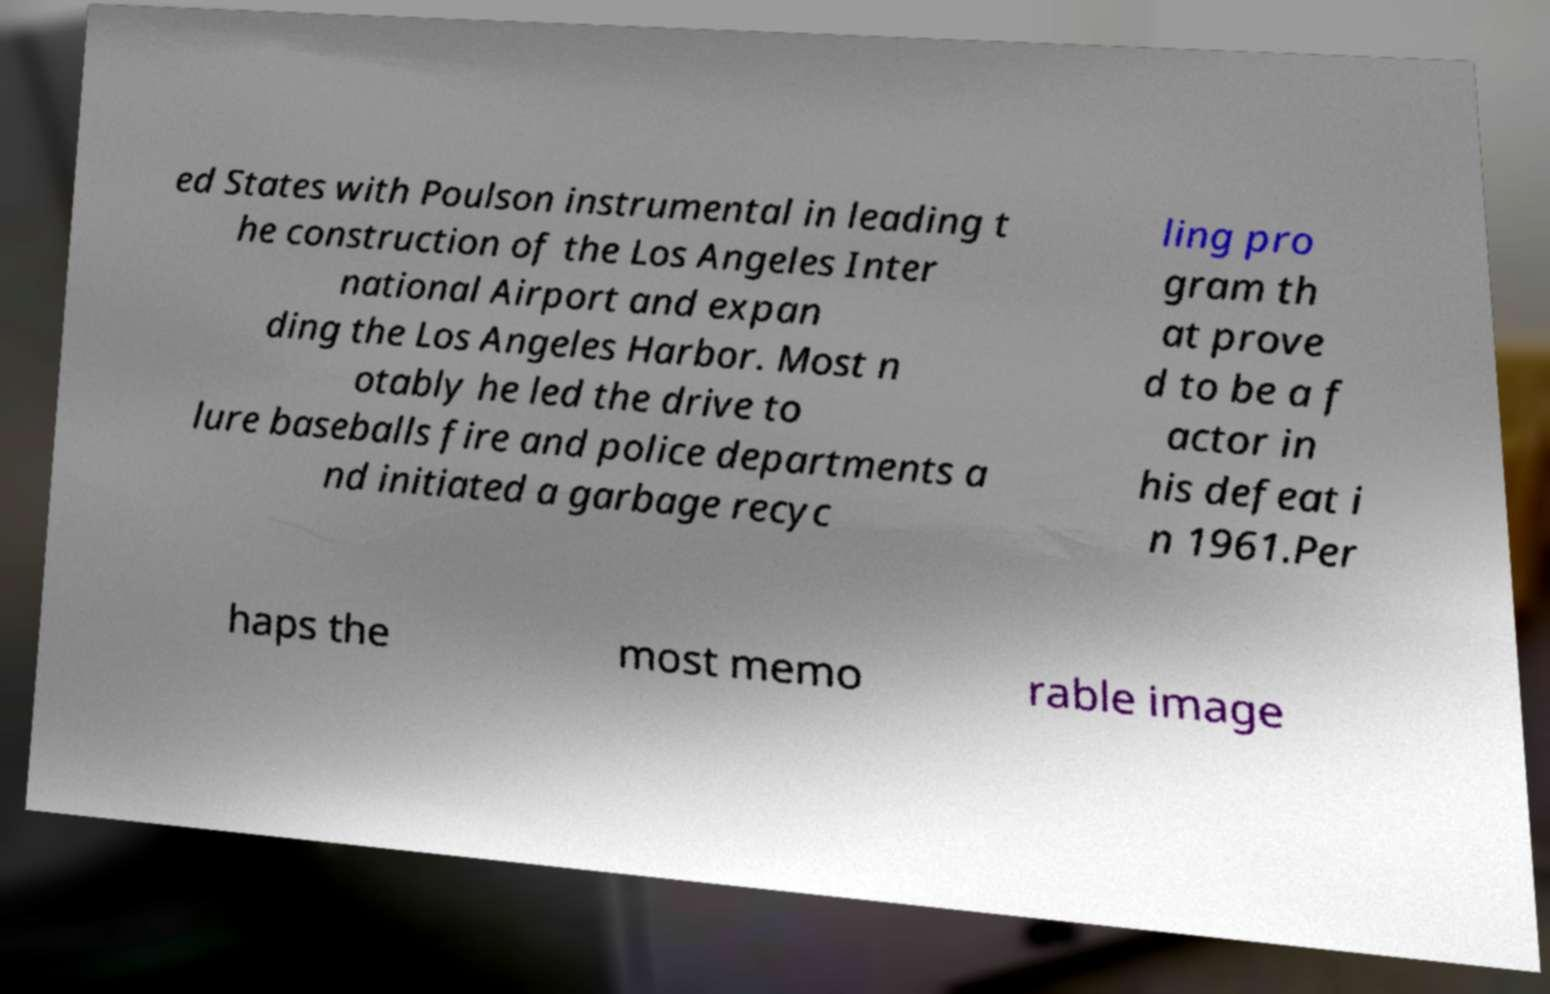Could you assist in decoding the text presented in this image and type it out clearly? ed States with Poulson instrumental in leading t he construction of the Los Angeles Inter national Airport and expan ding the Los Angeles Harbor. Most n otably he led the drive to lure baseballs fire and police departments a nd initiated a garbage recyc ling pro gram th at prove d to be a f actor in his defeat i n 1961.Per haps the most memo rable image 